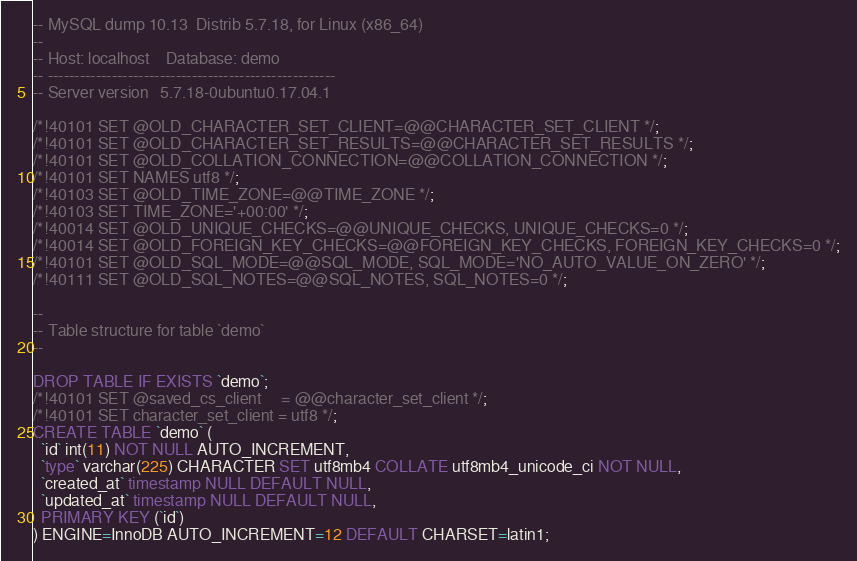<code> <loc_0><loc_0><loc_500><loc_500><_SQL_>-- MySQL dump 10.13  Distrib 5.7.18, for Linux (x86_64)
--
-- Host: localhost    Database: demo
-- ------------------------------------------------------
-- Server version	5.7.18-0ubuntu0.17.04.1

/*!40101 SET @OLD_CHARACTER_SET_CLIENT=@@CHARACTER_SET_CLIENT */;
/*!40101 SET @OLD_CHARACTER_SET_RESULTS=@@CHARACTER_SET_RESULTS */;
/*!40101 SET @OLD_COLLATION_CONNECTION=@@COLLATION_CONNECTION */;
/*!40101 SET NAMES utf8 */;
/*!40103 SET @OLD_TIME_ZONE=@@TIME_ZONE */;
/*!40103 SET TIME_ZONE='+00:00' */;
/*!40014 SET @OLD_UNIQUE_CHECKS=@@UNIQUE_CHECKS, UNIQUE_CHECKS=0 */;
/*!40014 SET @OLD_FOREIGN_KEY_CHECKS=@@FOREIGN_KEY_CHECKS, FOREIGN_KEY_CHECKS=0 */;
/*!40101 SET @OLD_SQL_MODE=@@SQL_MODE, SQL_MODE='NO_AUTO_VALUE_ON_ZERO' */;
/*!40111 SET @OLD_SQL_NOTES=@@SQL_NOTES, SQL_NOTES=0 */;

--
-- Table structure for table `demo`
--

DROP TABLE IF EXISTS `demo`;
/*!40101 SET @saved_cs_client     = @@character_set_client */;
/*!40101 SET character_set_client = utf8 */;
CREATE TABLE `demo` (
  `id` int(11) NOT NULL AUTO_INCREMENT,
  `type` varchar(225) CHARACTER SET utf8mb4 COLLATE utf8mb4_unicode_ci NOT NULL,
  `created_at` timestamp NULL DEFAULT NULL,
  `updated_at` timestamp NULL DEFAULT NULL,
  PRIMARY KEY (`id`)
) ENGINE=InnoDB AUTO_INCREMENT=12 DEFAULT CHARSET=latin1;</code> 